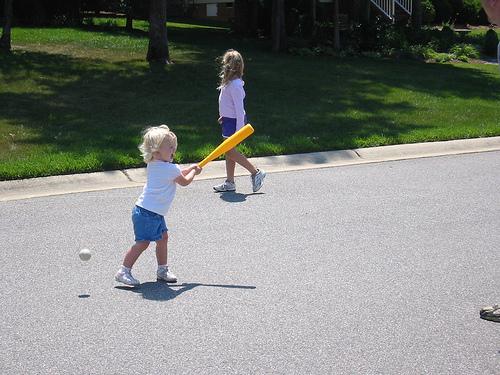Do these two children appear to be the same age?
Answer briefly. No. Is the player good?
Quick response, please. No. What color is the boy on the lefts pants?
Quick response, please. Blue. How many people are depicted?
Write a very short answer. 2. Did the girl just hit the ball?
Write a very short answer. No. What is this person playing?
Be succinct. Baseball. Is the girl skateboarding?
Quick response, please. No. What is this child practicing?
Keep it brief. Baseball. Are they playing in the street?
Be succinct. Yes. Are both children over 5 years old?
Write a very short answer. No. What color are the girl's shoes?
Keep it brief. White. What are the people doing?
Give a very brief answer. Playing baseball. How many people are in this photo?
Give a very brief answer. 2. Are they in a park?
Answer briefly. No. What are the girls doing?
Give a very brief answer. Playing baseball. What sport is shown?
Answer briefly. Baseball. What is the boy riding?
Write a very short answer. Nothing. 